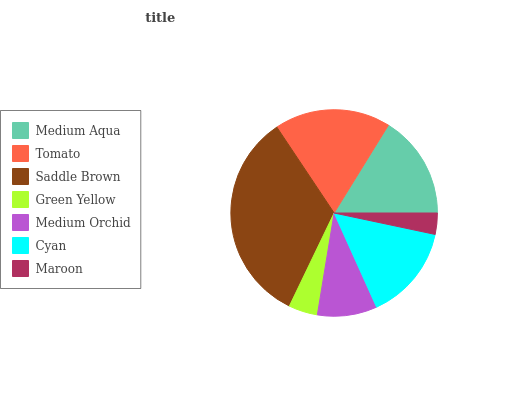Is Maroon the minimum?
Answer yes or no. Yes. Is Saddle Brown the maximum?
Answer yes or no. Yes. Is Tomato the minimum?
Answer yes or no. No. Is Tomato the maximum?
Answer yes or no. No. Is Tomato greater than Medium Aqua?
Answer yes or no. Yes. Is Medium Aqua less than Tomato?
Answer yes or no. Yes. Is Medium Aqua greater than Tomato?
Answer yes or no. No. Is Tomato less than Medium Aqua?
Answer yes or no. No. Is Cyan the high median?
Answer yes or no. Yes. Is Cyan the low median?
Answer yes or no. Yes. Is Medium Aqua the high median?
Answer yes or no. No. Is Medium Orchid the low median?
Answer yes or no. No. 